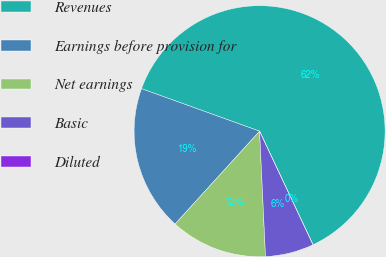Convert chart to OTSL. <chart><loc_0><loc_0><loc_500><loc_500><pie_chart><fcel>Revenues<fcel>Earnings before provision for<fcel>Net earnings<fcel>Basic<fcel>Diluted<nl><fcel>62.5%<fcel>18.75%<fcel>12.5%<fcel>6.25%<fcel>0.0%<nl></chart> 